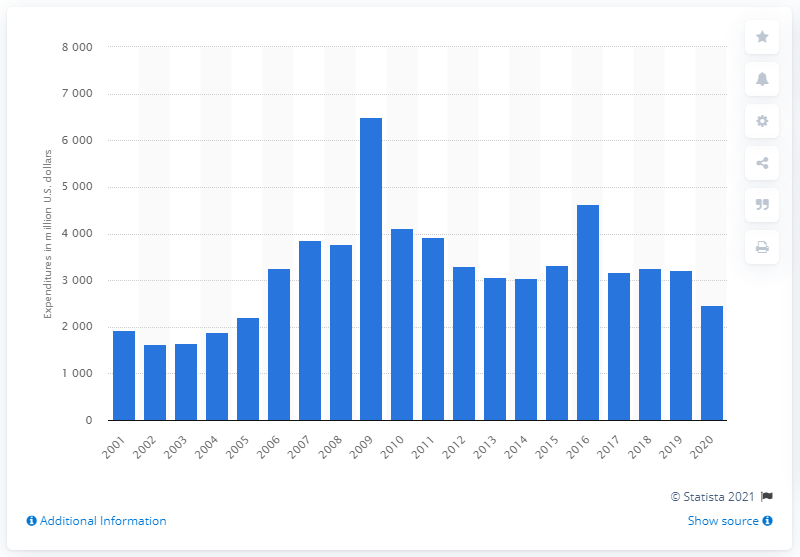What might have caused the peak in 2009? The peak in 2009 may have been influenced by various factors, including increased investment in innovation as a response to the global financial crisis of 2008, aiming to stimulate economic growth through technological advances and improved competitiveness. Can we determine the specific area of research most invested in during that year? Without additional data specifying the categories of research, it's not possible to determine from this chart alone which specific area received the most investment in 2009. However, typically areas like healthcare, information technology, and clean energy are common fields of research investment. 